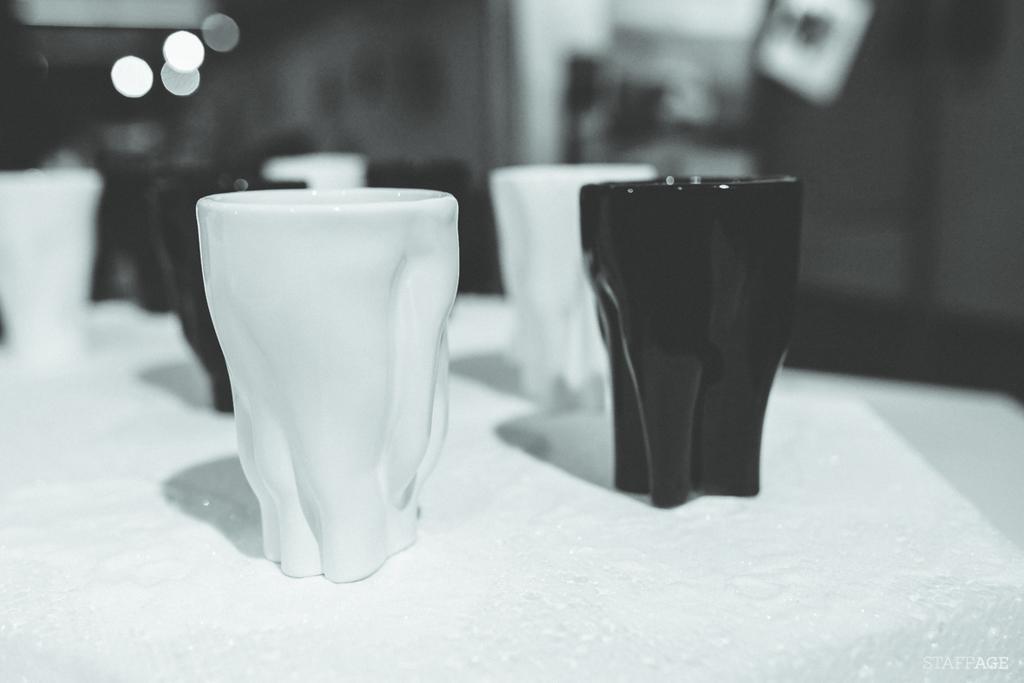Can you describe this image briefly? This is a black and white picture. On the table there are cups, the cups are in black and white color. Behind the cups is in blue. 